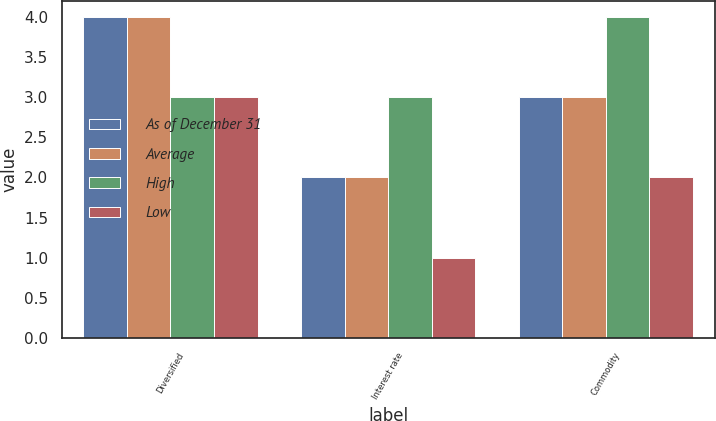Convert chart. <chart><loc_0><loc_0><loc_500><loc_500><stacked_bar_chart><ecel><fcel>Diversified<fcel>Interest rate<fcel>Commodity<nl><fcel>As of December 31<fcel>4<fcel>2<fcel>3<nl><fcel>Average<fcel>4<fcel>2<fcel>3<nl><fcel>High<fcel>3<fcel>3<fcel>4<nl><fcel>Low<fcel>3<fcel>1<fcel>2<nl></chart> 